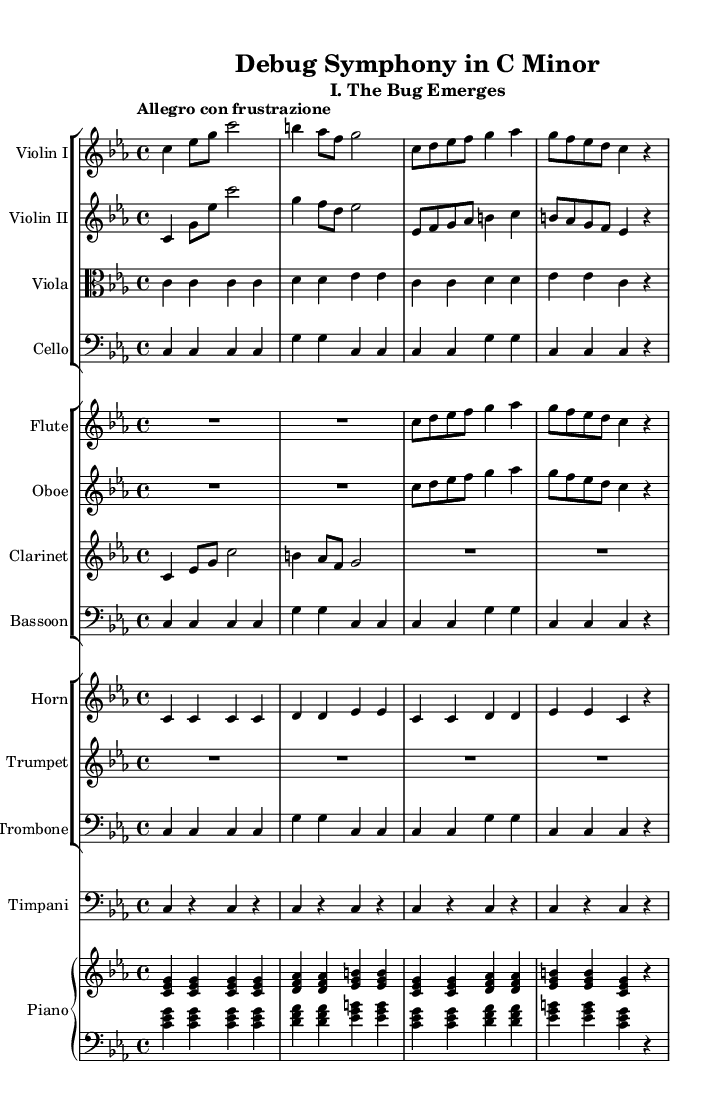What is the key signature of this music? The key signature is indicated at the beginning of the score and shows that there are three flats, which corresponds to C minor.
Answer: C minor What is the time signature of this symphony? The time signature is located at the beginning of the score and indicates that there are four beats in a measure, specifically 4/4 time.
Answer: 4/4 What is the tempo marking for the first movement? The tempo marking is found above the staff in the score, stating "Allegro con frustrazione," which describes the speed and mood of the piece.
Answer: Allegro con frustrazione How many different instruments are featured in this symphony? By counting the distinct staff groups and individual instruments listed in the score, we identify there are fifteen instruments total.
Answer: Fifteen Describe the emotional theme conveyed in the title of the symphony. The title "Debug Symphony in C Minor" suggests a focus on the struggles and emotional challenges associated with debugging software, which is often complicated and frustrating.
Answer: Debugging emotions Which instrument has the main melody in the opening section? Examining the score, Violin I has a prominent melodic line at the beginning, playing the initial motif that leads into the overall theme of the symphony.
Answer: Violin I What is the role of the timpani in this movement? The timpani in this movement primarily provides rhythmic support and dramatic emphasis, contributing to the overall tension that parallels software debugging scenarios in the music.
Answer: Rhythmic support 